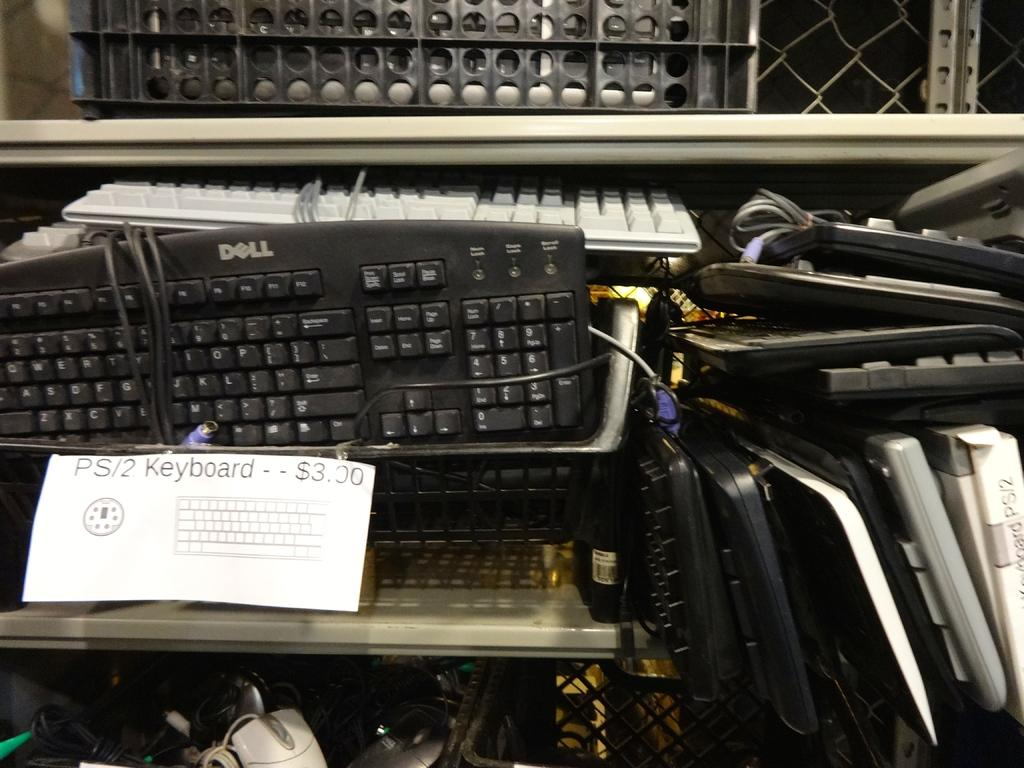<image>
Give a short and clear explanation of the subsequent image. A bunch of old keyboards for sale at a used store. 